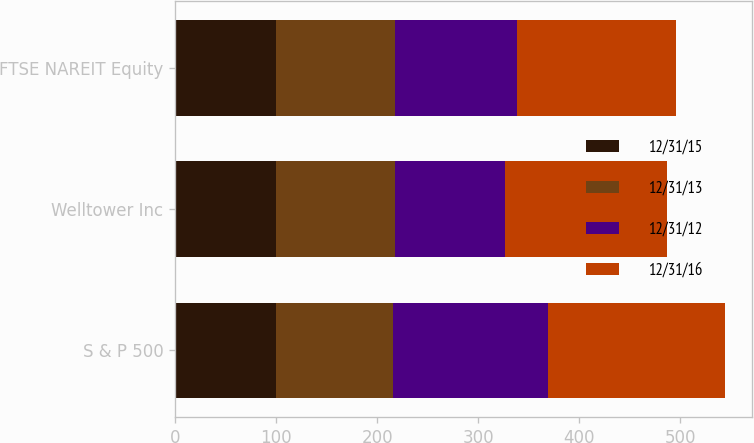Convert chart. <chart><loc_0><loc_0><loc_500><loc_500><stacked_bar_chart><ecel><fcel>S & P 500<fcel>Welltower Inc<fcel>FTSE NAREIT Equity<nl><fcel>12/31/15<fcel>100<fcel>100<fcel>100<nl><fcel>12/31/13<fcel>116<fcel>118.21<fcel>118.06<nl><fcel>12/31/12<fcel>153.57<fcel>108.27<fcel>120.97<nl><fcel>12/31/16<fcel>174.6<fcel>160.79<fcel>157.43<nl></chart> 